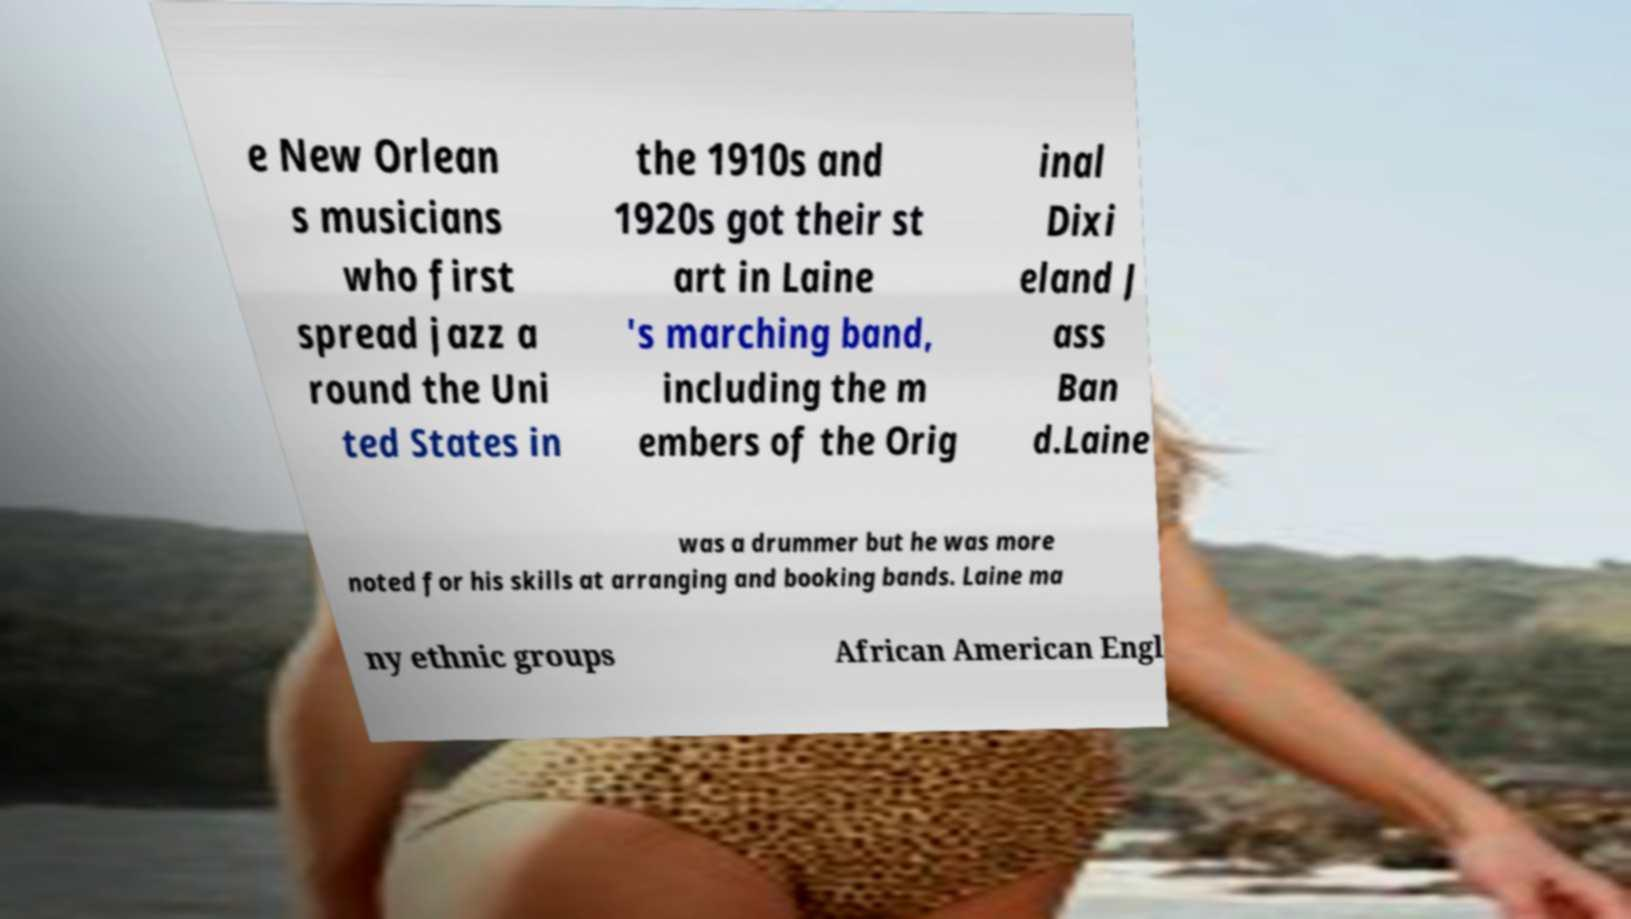Can you read and provide the text displayed in the image?This photo seems to have some interesting text. Can you extract and type it out for me? e New Orlean s musicians who first spread jazz a round the Uni ted States in the 1910s and 1920s got their st art in Laine 's marching band, including the m embers of the Orig inal Dixi eland J ass Ban d.Laine was a drummer but he was more noted for his skills at arranging and booking bands. Laine ma ny ethnic groups African American Engl 